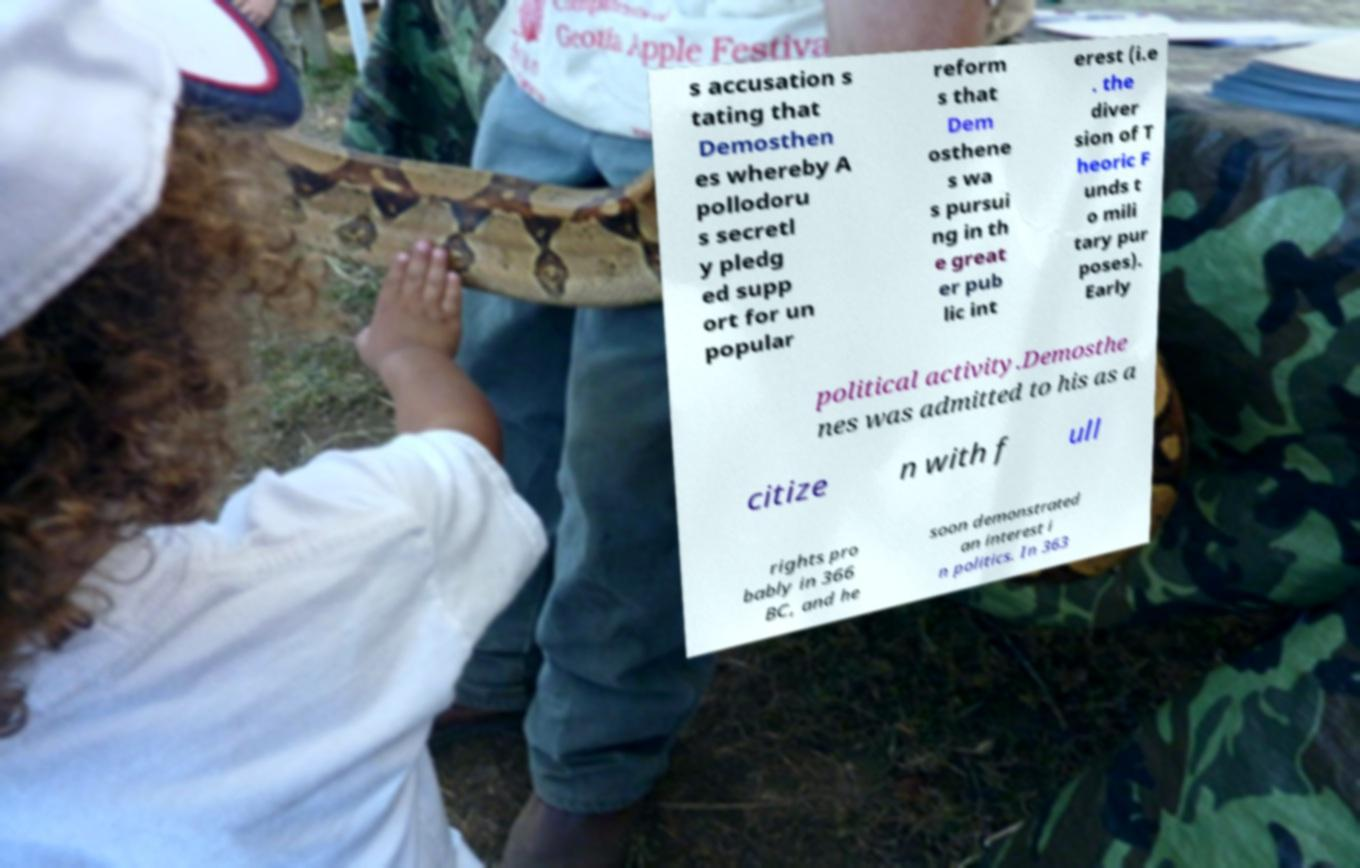Can you read and provide the text displayed in the image?This photo seems to have some interesting text. Can you extract and type it out for me? s accusation s tating that Demosthen es whereby A pollodoru s secretl y pledg ed supp ort for un popular reform s that Dem osthene s wa s pursui ng in th e great er pub lic int erest (i.e . the diver sion of T heoric F unds t o mili tary pur poses). Early political activity.Demosthe nes was admitted to his as a citize n with f ull rights pro bably in 366 BC, and he soon demonstrated an interest i n politics. In 363 